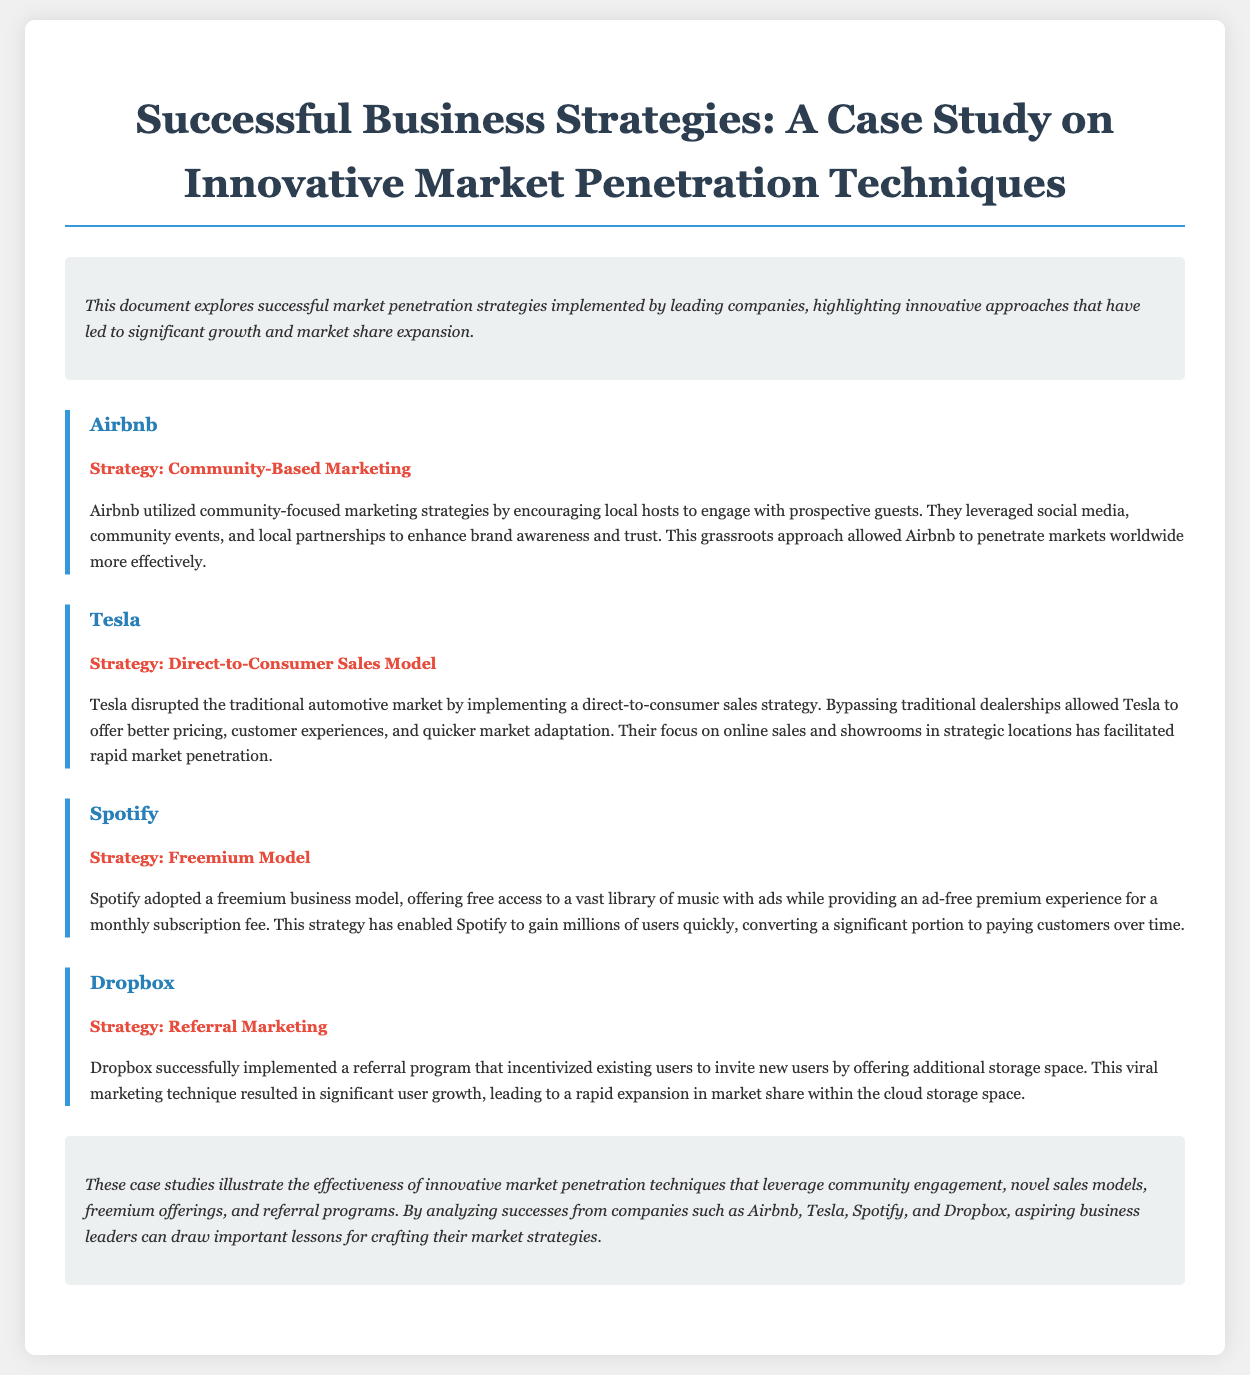What strategy did Airbnb implement? The strategy used by Airbnb was a community-focused marketing strategy.
Answer: Community-Based Marketing What sales model did Tesla use? Tesla implemented a direct-to-consumer sales strategy bypassing traditional dealerships.
Answer: Direct-to-Consumer Sales Model What marketing approach did Dropbox utilize? Dropbox's marketing approach involved a referral program incentivizing user invitations.
Answer: Referral Marketing What type of business model did Spotify adopt? Spotify adopted a freemium business model offering both free and premium services.
Answer: Freemium Model Which company encouraged local hosts for brand awareness? The company that utilized local hosts to enhance brand awareness was Airbnb.
Answer: Airbnb How did Dropbox's referral program impact user growth? Dropbox's referral program caused significant user growth leading to market share expansion.
Answer: Significant user growth What is one common theme found in the case studies? A common theme in the case studies is the use of innovative market penetration techniques.
Answer: Innovative market penetration techniques How many case studies are presented in the document? The document presents four case studies.
Answer: Four 